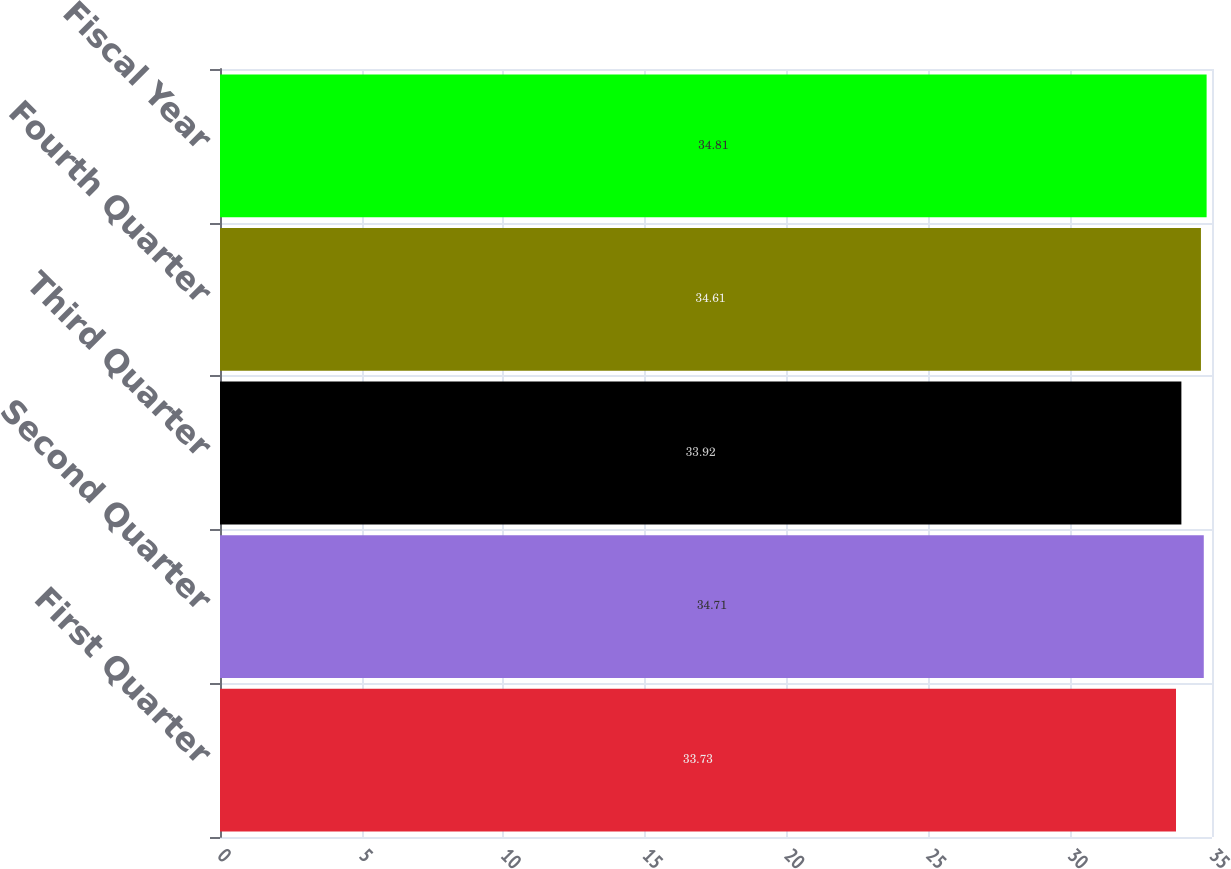<chart> <loc_0><loc_0><loc_500><loc_500><bar_chart><fcel>First Quarter<fcel>Second Quarter<fcel>Third Quarter<fcel>Fourth Quarter<fcel>Fiscal Year<nl><fcel>33.73<fcel>34.71<fcel>33.92<fcel>34.61<fcel>34.81<nl></chart> 